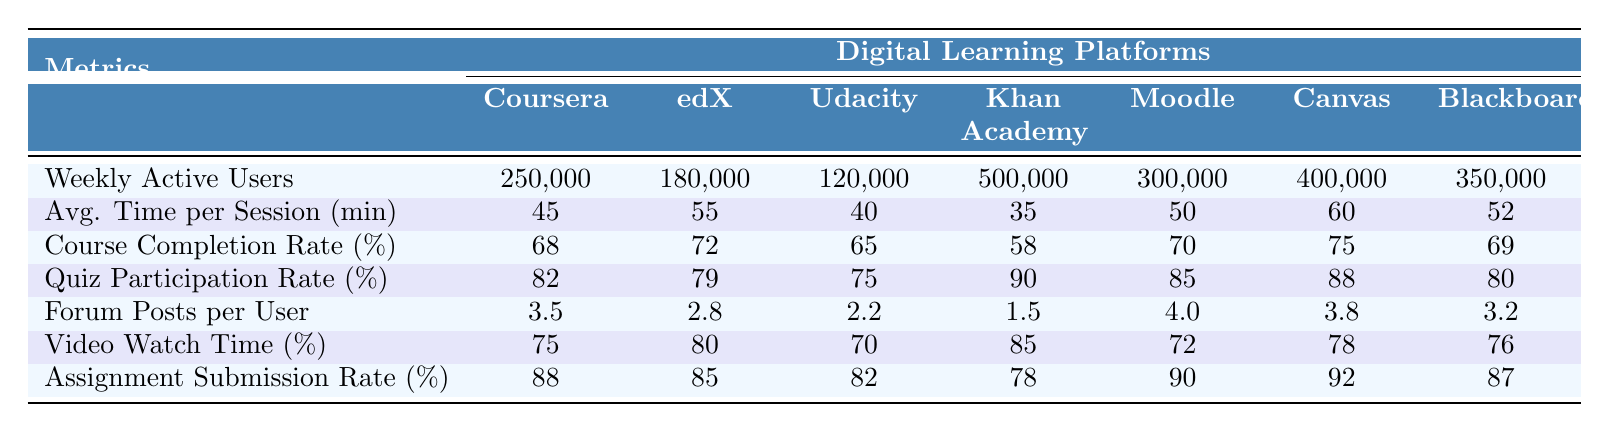What is the course completion rate for Coursera? The course completion rate is specifically listed for each platform. Coursera's course completion rate is 68%.
Answer: 68% Which platform has the highest video watch time percentage? By comparing the video watch time percentages across all platforms, we see that Khan Academy has the highest at 85%.
Answer: 85% What is the average assignment submission rate across all platforms? To find the average, we sum the assignment submission rates (88 + 85 + 82 + 78 + 90 + 92 + 87) = 522, and then divide by the number of platforms (7). So, the average is 522 / 7 = 74.57%.
Answer: 74.57% True or False: Moodle has a higher average time spent per session than Canvas. Moodle's average time spent per session is 50 minutes, while Canvas's is 60 minutes. Since 50 < 60, the statement is false.
Answer: False Which platform has the lowest weekly active users and what is that number? By looking at the weekly active users for each platform, we see that Udacity has the lowest with 120,000 users.
Answer: 120,000 Calculate the difference in quiz participation rates between edX and Khan Academy. The quiz participation rate for edX is 79% and for Khan Academy is 90%. The difference is 90 - 79 = 11%.
Answer: 11% Which platform has the highest forum posts per user? Upon reviewing the data for forum posts per user, we find Moodle has the highest at 4.0 posts per user.
Answer: 4.0 Is the average time spent per session for Blackboard higher than 50 minutes? Blackboard has an average time spent per session of 52 minutes. Since 52 > 50, the answer is yes.
Answer: Yes Rank the platforms from highest to lowest in terms of course completion rates. The completion rates are as follows: Canvas (75%), edX (72%), Moodle (70%), Blackboard (69%), Coursera (68%), Udacity (65%), and Khan Academy (58%). This gives us the ranking: Canvas, edX, Moodle, Blackboard, Coursera, Udacity, Khan Academy.
Answer: Canvas, edX, Moodle, Blackboard, Coursera, Udacity, Khan Academy What is the comparison of weekly active users between Coursera and Khan Academy? Coursera has 250,000 weekly active users while Khan Academy has 500,000. Therefore, Khan Academy has more weekly active users than Coursera, specifically 250,000 fewer users than Khan Academy.
Answer: Khan Academy has more users 